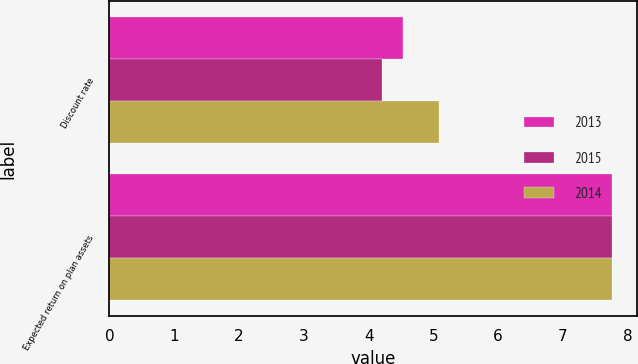Convert chart to OTSL. <chart><loc_0><loc_0><loc_500><loc_500><stacked_bar_chart><ecel><fcel>Discount rate<fcel>Expected return on plan assets<nl><fcel>2013<fcel>4.53<fcel>7.75<nl><fcel>2015<fcel>4.21<fcel>7.75<nl><fcel>2014<fcel>5.08<fcel>7.75<nl></chart> 